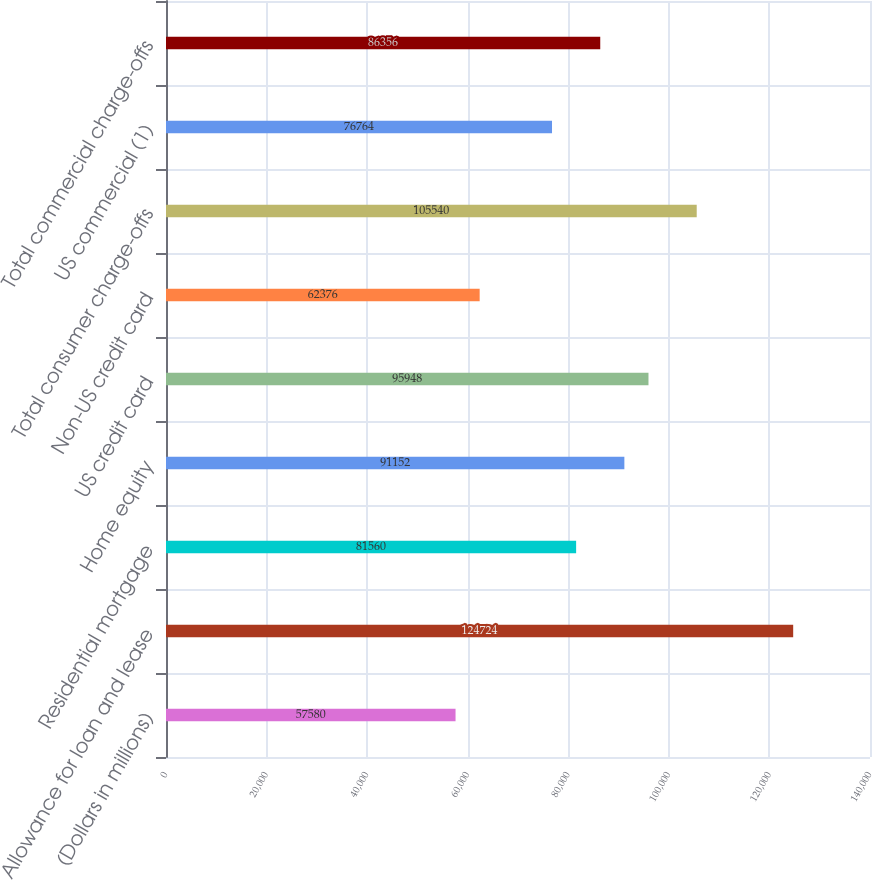Convert chart to OTSL. <chart><loc_0><loc_0><loc_500><loc_500><bar_chart><fcel>(Dollars in millions)<fcel>Allowance for loan and lease<fcel>Residential mortgage<fcel>Home equity<fcel>US credit card<fcel>Non-US credit card<fcel>Total consumer charge-offs<fcel>US commercial (1)<fcel>Total commercial charge-offs<nl><fcel>57580<fcel>124724<fcel>81560<fcel>91152<fcel>95948<fcel>62376<fcel>105540<fcel>76764<fcel>86356<nl></chart> 